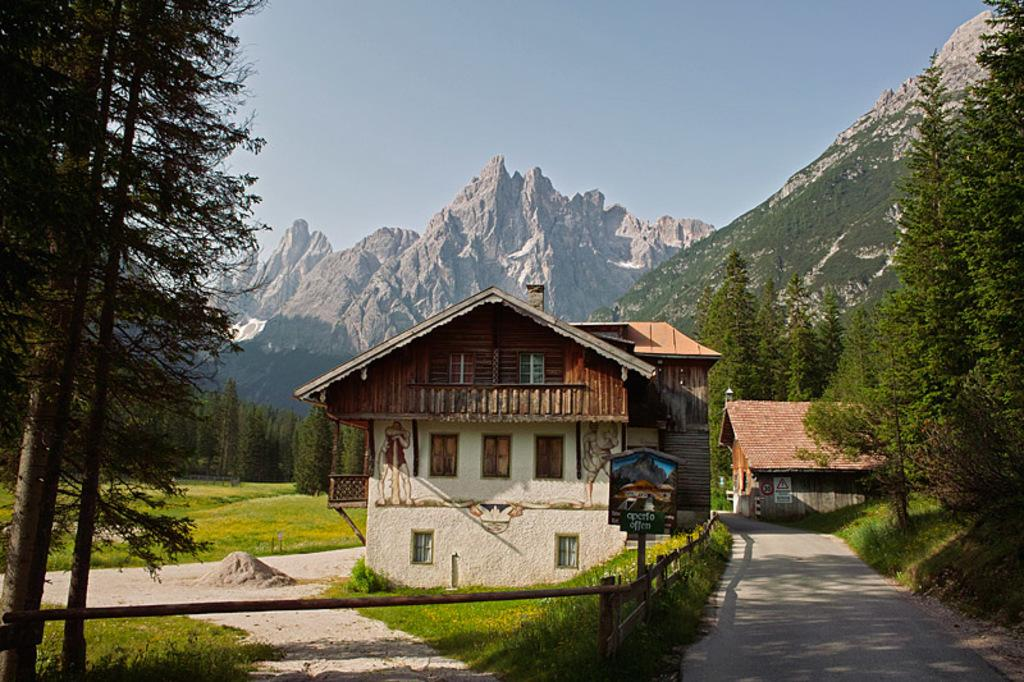What type of structure is in the image? There is a house in the image. What color is the house? The house is cream-colored. What can be seen in the background of the image? There are trees, grass, mountains, and the sky visible in the background. What color are the trees and grass? The trees and grass are green. What color is the sky? The sky is blue. What type of feather can be seen in the image? There is no feather present in the image. What is the condition of the camera used to take the image? The image does not provide information about the condition of the camera used to take the image. 